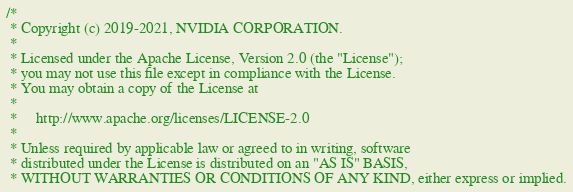Convert code to text. <code><loc_0><loc_0><loc_500><loc_500><_Cuda_>/*
 * Copyright (c) 2019-2021, NVIDIA CORPORATION.
 *
 * Licensed under the Apache License, Version 2.0 (the "License");
 * you may not use this file except in compliance with the License.
 * You may obtain a copy of the License at
 *
 *     http://www.apache.org/licenses/LICENSE-2.0
 *
 * Unless required by applicable law or agreed to in writing, software
 * distributed under the License is distributed on an "AS IS" BASIS,
 * WITHOUT WARRANTIES OR CONDITIONS OF ANY KIND, either express or implied.</code> 